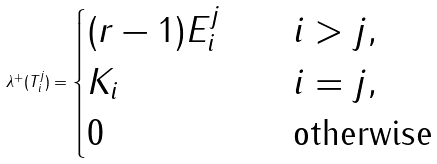<formula> <loc_0><loc_0><loc_500><loc_500>\lambda ^ { + } ( T _ { i } ^ { j } ) = \begin{cases} ( r - 1 ) E _ { i } ^ { j } \quad & i > j , \\ K _ { i } \quad & i = j , \\ 0 \quad & \text {otherwise} \end{cases}</formula> 